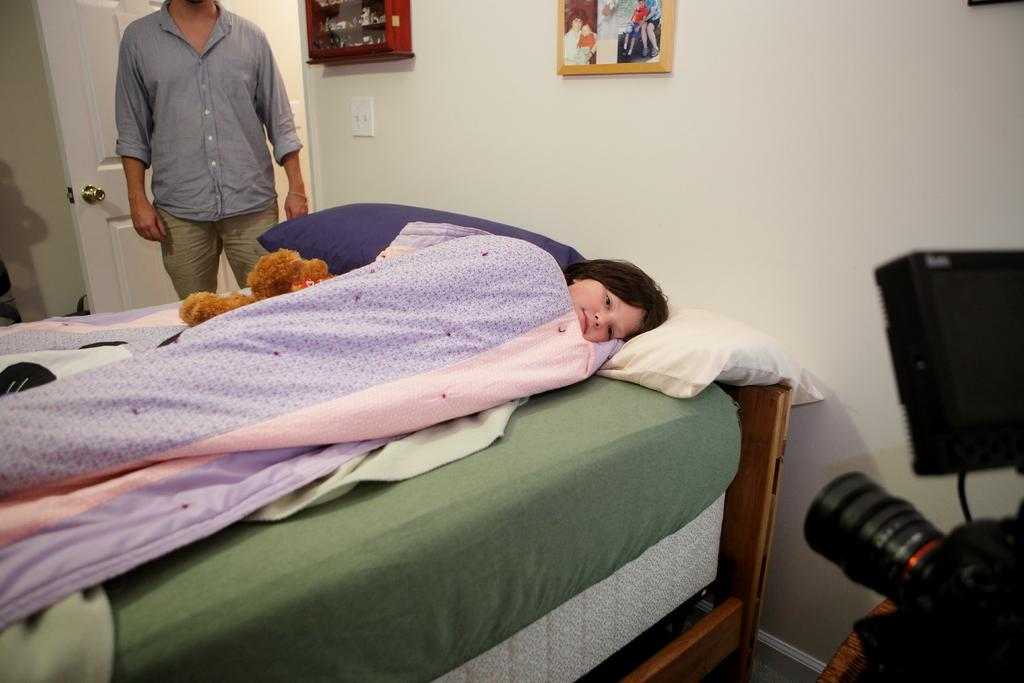What is the woman doing in the image? There is a woman sleeping on a bed in the image. What is the man doing in the image? There is a man standing near the door in the image. What object can be seen on the right side of the image? There is a camera on the right side of the image. How is the image displayed in the room? The image is a photo frame fixed to a wall. How many boys are visible in the image? There are no boys visible in the image; it features a woman sleeping on a bed and a man standing near the door. What type of wrench is being used by the woman in the image? There is no wrench present in the image; the woman is sleeping on a bed. 